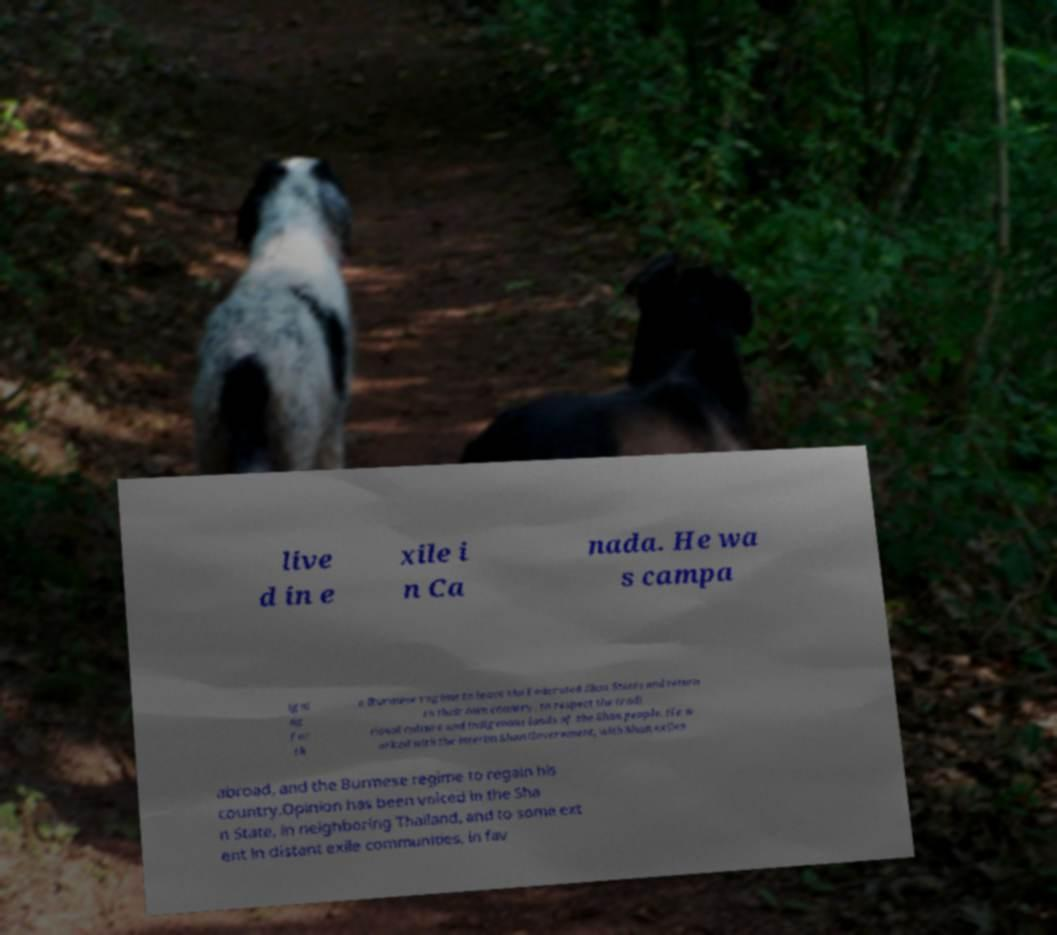There's text embedded in this image that I need extracted. Can you transcribe it verbatim? live d in e xile i n Ca nada. He wa s campa igni ng for th e Burmese regime to leave the Federated Shan States and return to their own country, to respect the tradi tional culture and indigenous lands of the Shan people. He w orked with the interim Shan Government, with Shan exiles abroad, and the Burmese regime to regain his country.Opinion has been voiced in the Sha n State, in neighboring Thailand, and to some ext ent in distant exile communities, in fav 